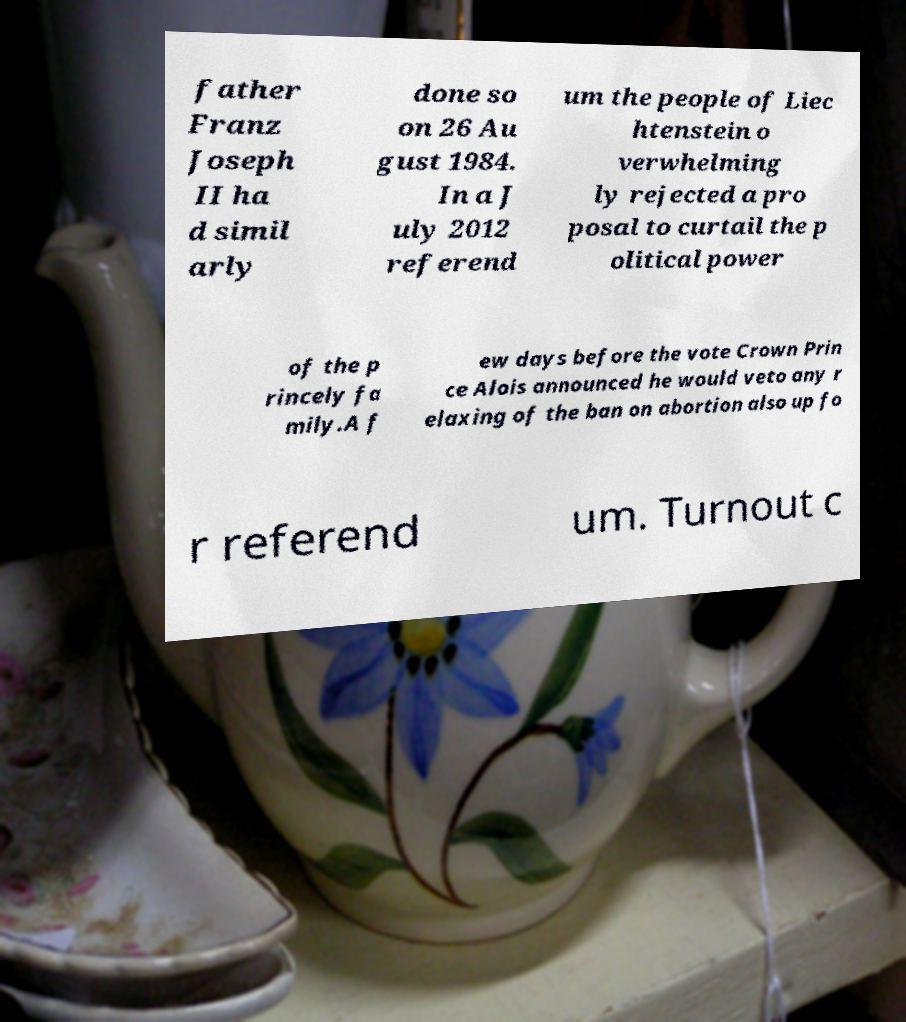Could you assist in decoding the text presented in this image and type it out clearly? father Franz Joseph II ha d simil arly done so on 26 Au gust 1984. In a J uly 2012 referend um the people of Liec htenstein o verwhelming ly rejected a pro posal to curtail the p olitical power of the p rincely fa mily.A f ew days before the vote Crown Prin ce Alois announced he would veto any r elaxing of the ban on abortion also up fo r referend um. Turnout c 